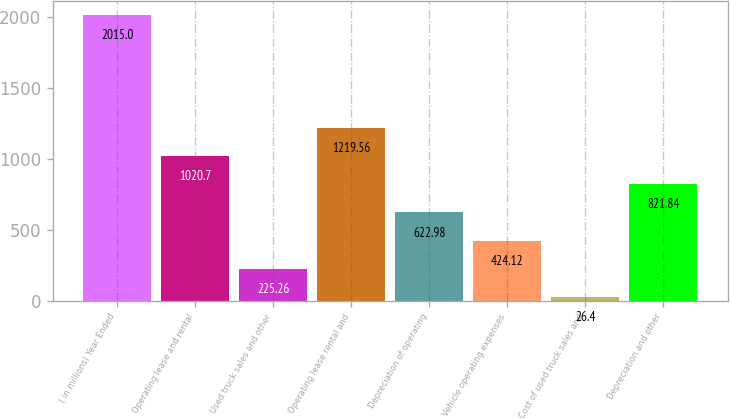Convert chart to OTSL. <chart><loc_0><loc_0><loc_500><loc_500><bar_chart><fcel>( in millions) Year Ended<fcel>Operating lease and rental<fcel>Used truck sales and other<fcel>Operating lease rental and<fcel>Depreciation of operating<fcel>Vehicle operating expenses<fcel>Cost of used truck sales and<fcel>Depreciation and other<nl><fcel>2015<fcel>1020.7<fcel>225.26<fcel>1219.56<fcel>622.98<fcel>424.12<fcel>26.4<fcel>821.84<nl></chart> 